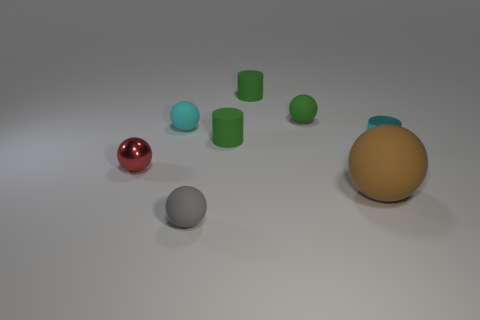What might be the purpose of creating and capturing this scene? This scene could serve several purposes, such as demonstrating 3D rendering techniques or materials in computer graphics. It may also be used in an educational context to teach about colors, shapes, and spatial relationships, or as a visual puzzle designed to prompt questions about geometry and perspective. 